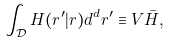<formula> <loc_0><loc_0><loc_500><loc_500>\int _ { \mathcal { D } } H ( { r } ^ { \prime } | { r } ) d ^ { d } { r } ^ { \prime } \equiv V \bar { H } ,</formula> 